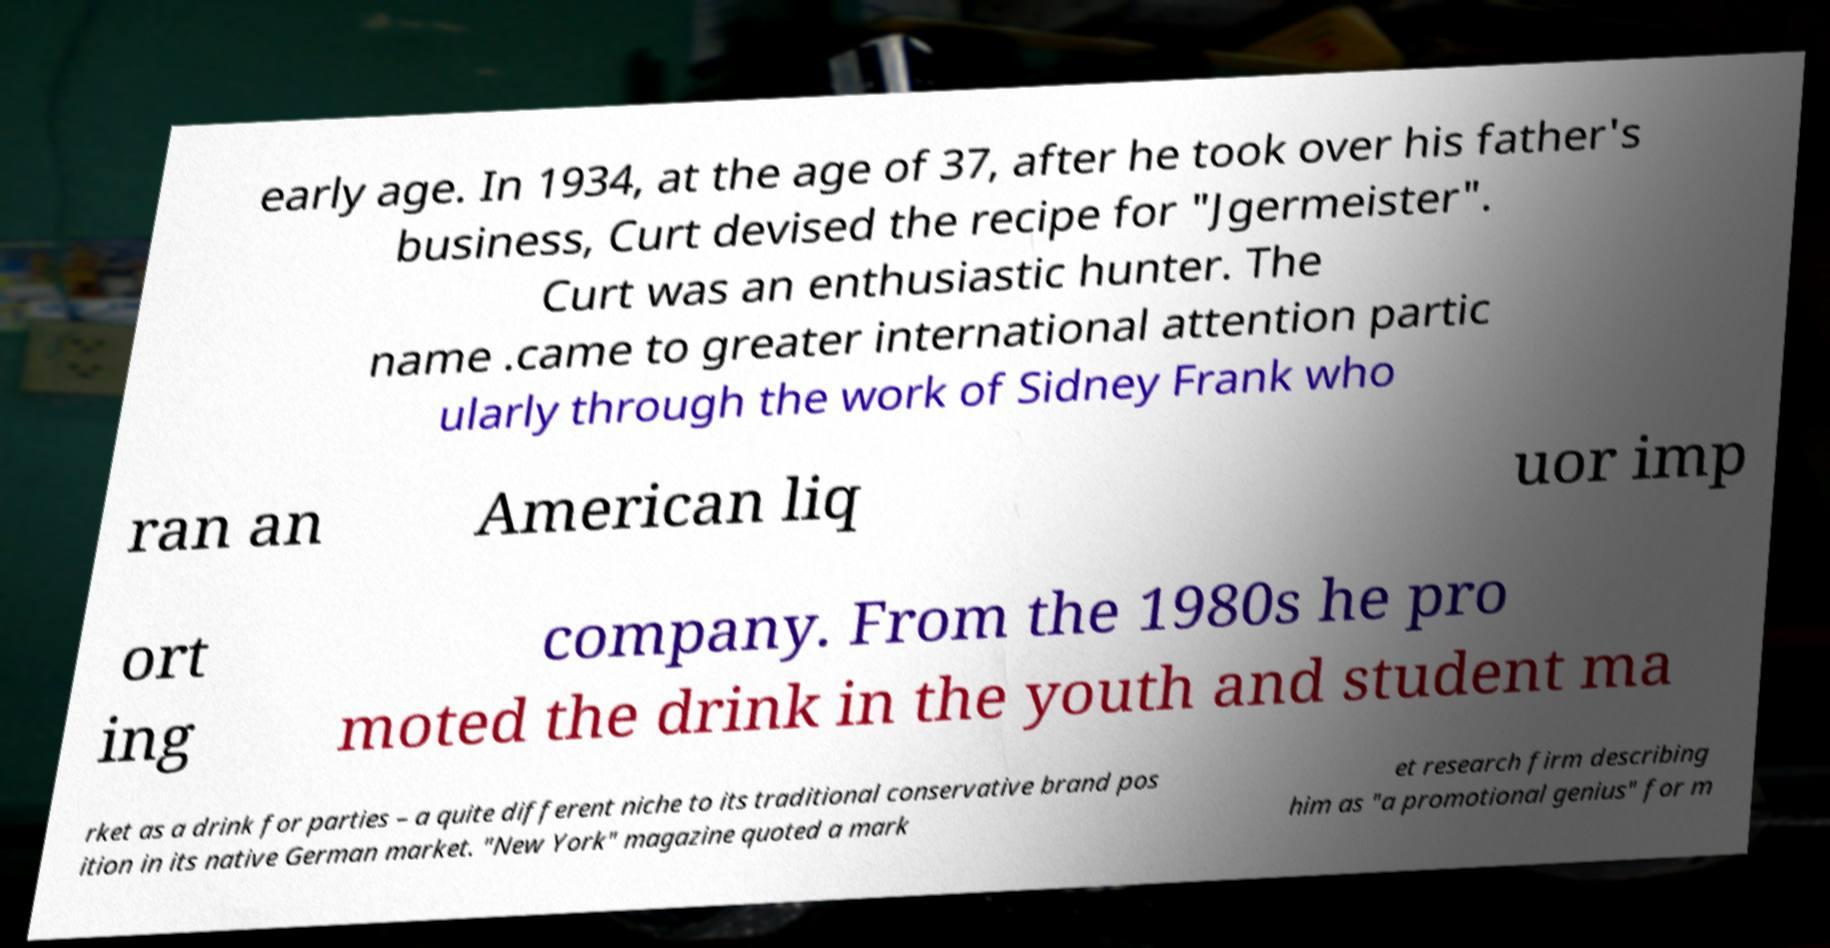What messages or text are displayed in this image? I need them in a readable, typed format. early age. In 1934, at the age of 37, after he took over his father's business, Curt devised the recipe for "Jgermeister". Curt was an enthusiastic hunter. The name .came to greater international attention partic ularly through the work of Sidney Frank who ran an American liq uor imp ort ing company. From the 1980s he pro moted the drink in the youth and student ma rket as a drink for parties – a quite different niche to its traditional conservative brand pos ition in its native German market. "New York" magazine quoted a mark et research firm describing him as "a promotional genius" for m 